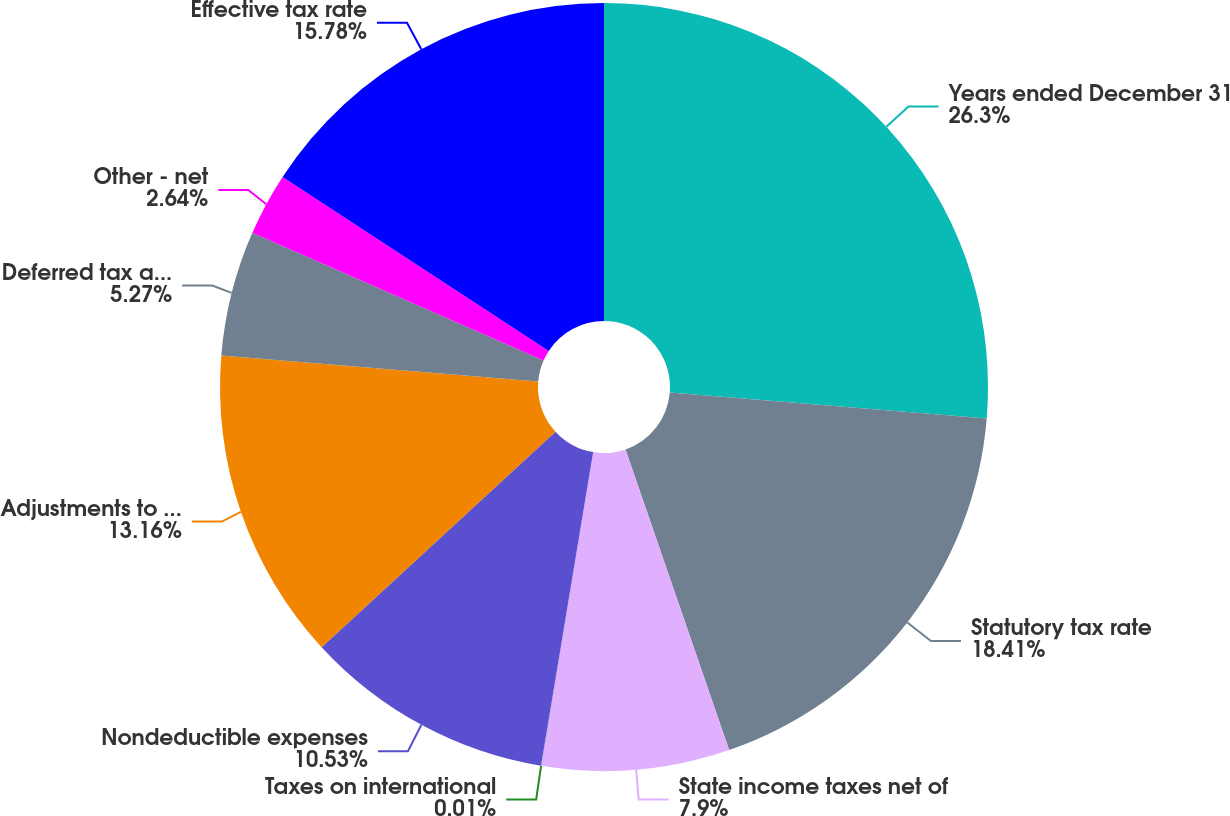<chart> <loc_0><loc_0><loc_500><loc_500><pie_chart><fcel>Years ended December 31<fcel>Statutory tax rate<fcel>State income taxes net of<fcel>Taxes on international<fcel>Nondeductible expenses<fcel>Adjustments to prior year tax<fcel>Deferred tax adjustments<fcel>Other - net<fcel>Effective tax rate<nl><fcel>26.31%<fcel>18.42%<fcel>7.9%<fcel>0.01%<fcel>10.53%<fcel>13.16%<fcel>5.27%<fcel>2.64%<fcel>15.79%<nl></chart> 